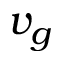Convert formula to latex. <formula><loc_0><loc_0><loc_500><loc_500>v _ { g }</formula> 